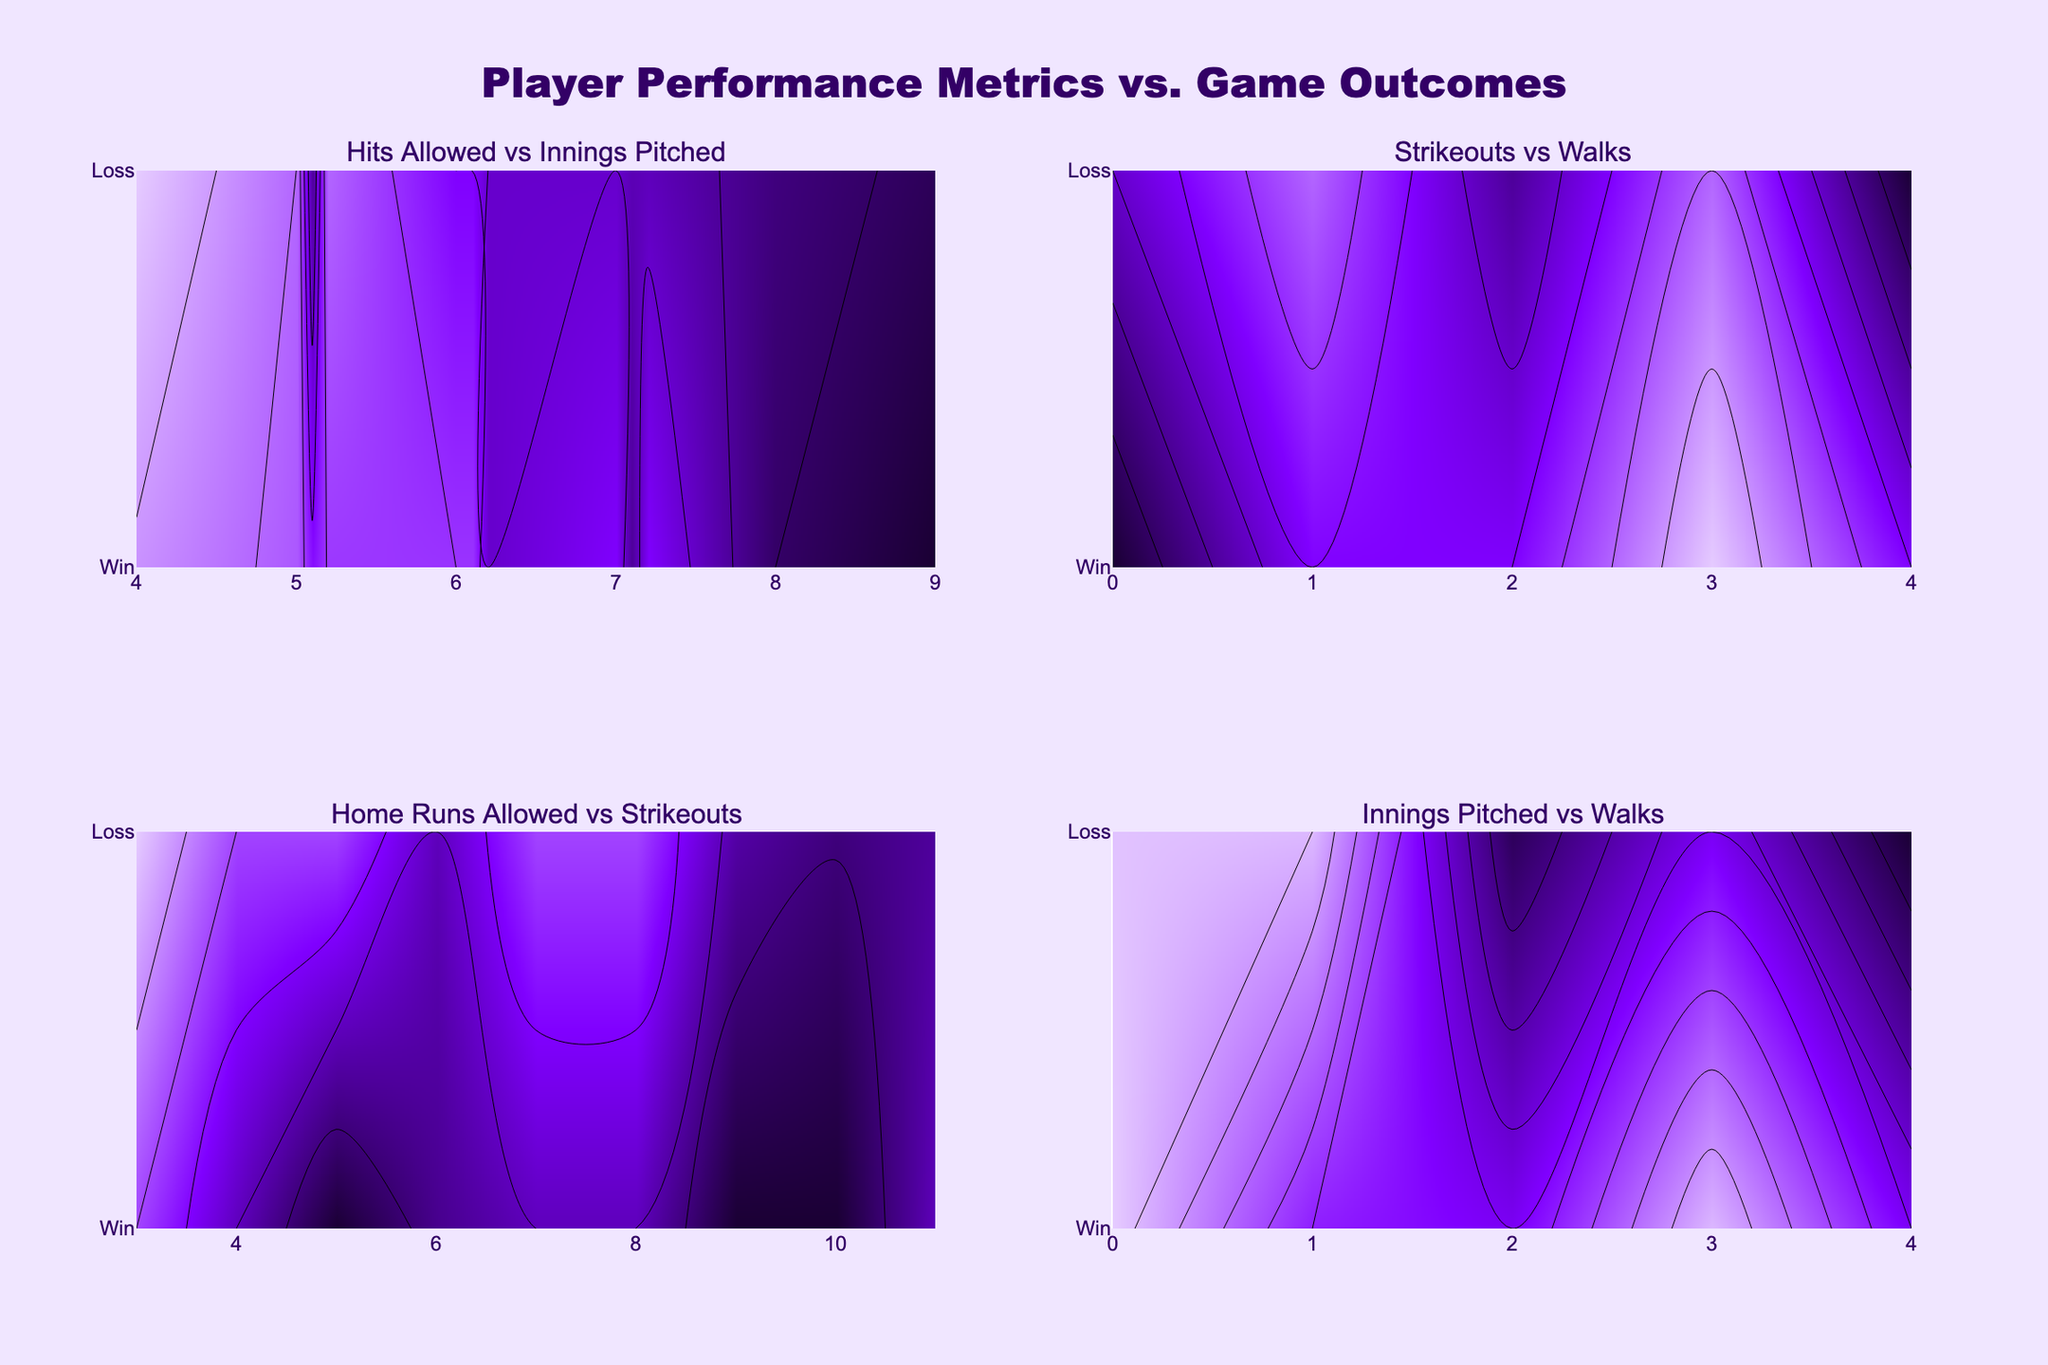What's the title of the figure? The title can be easily found at the top center of the figure. It's usually in a larger or bolder font compared to other text.
Answer: "Player Performance Metrics vs. Game Outcomes" What color scheme is used in the plot? The color scheme can be seen in the gradient of colors used to represent different levels in the contour plots.
Answer: Shades of purple (from dark purple to light purple) Which subplot shows the relationship between Strikeouts and Walks? The location of each subplot can be identified by its title, which describes the metrics being compared.
Answer: Top right subplot How do Innings Pitched correlate with Game Outcomes in the "Hits Allowed vs Innings Pitched" subplot? By looking at how the values change along the axes for Innings Pitched and Game Outcomes in the subplot, one can observe any patterns or trends.
Answer: Generally, more innings pitched seem to correlate with wins Is there a trend between Walks and Game Outcomes in the "Strikeouts vs Walks" subplot? By examining the contour patterns, especially the density and color variations between different walks values and their corresponding game outcomes, one can infer a relationship.
Answer: No clear trend is obvious Which subplot indicates the number of innings pitched for different numbers of walks? Each subplot title specifies the metrics plotted on the x and y axes, allowing identification of the subplot related to specific metrics.
Answer: Bottom right subplot Compare the contour patterns of "Home Runs Allowed vs Strikeouts" and "Strikeouts vs Walks". Which one shows more evenly distributed contours? This can be assessed by visually examining both subplots and noting the uniformity and spread of the contour lines.
Answer: "Home Runs Allowed vs Strikeouts" shows more evenly distributed contours Which subplot would you use to investigate anomalies in Strikeouts affecting Game Outcomes? Anomalies in Strikeouts affecting game outcomes can be best observed in the subplot that directly plots Game Outcomes against Strikeouts.
Answer: Top right subplot (Strikeouts vs Walks) In the "Hits Allowed vs Innings Pitched" subplot, do more hits typically lead to a consistent game outcome? By examining the contour lines and color changes, one can identify clusters or patterns that indicate consistent outcomes for specific hit values.
Answer: No, more hits do not lead to a consistent game outcome How is Walks' influence on Game Outcomes visualized across different subplots? Walks' influence can be seen in any subplot that includes Walks as one of its metrics. Observing how Walks interact with other metrics and Game Outcomes helps understand its effect.
Answer: Top right and bottom right subplots 